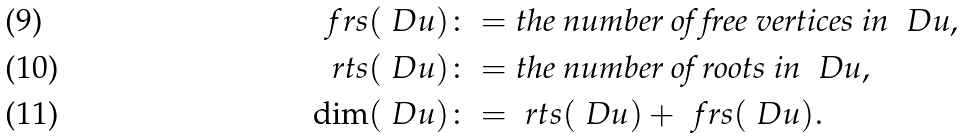<formula> <loc_0><loc_0><loc_500><loc_500>\ f r s ( \ D u ) & \colon = \text {the number of free vertices in } \ D u , \\ \ r t s ( \ D u ) & \colon = \text {the number of roots in } \ D u , \\ \dim ( \ D u ) & \colon = \ r t s ( \ D u ) + \ f r s ( \ D u ) .</formula> 